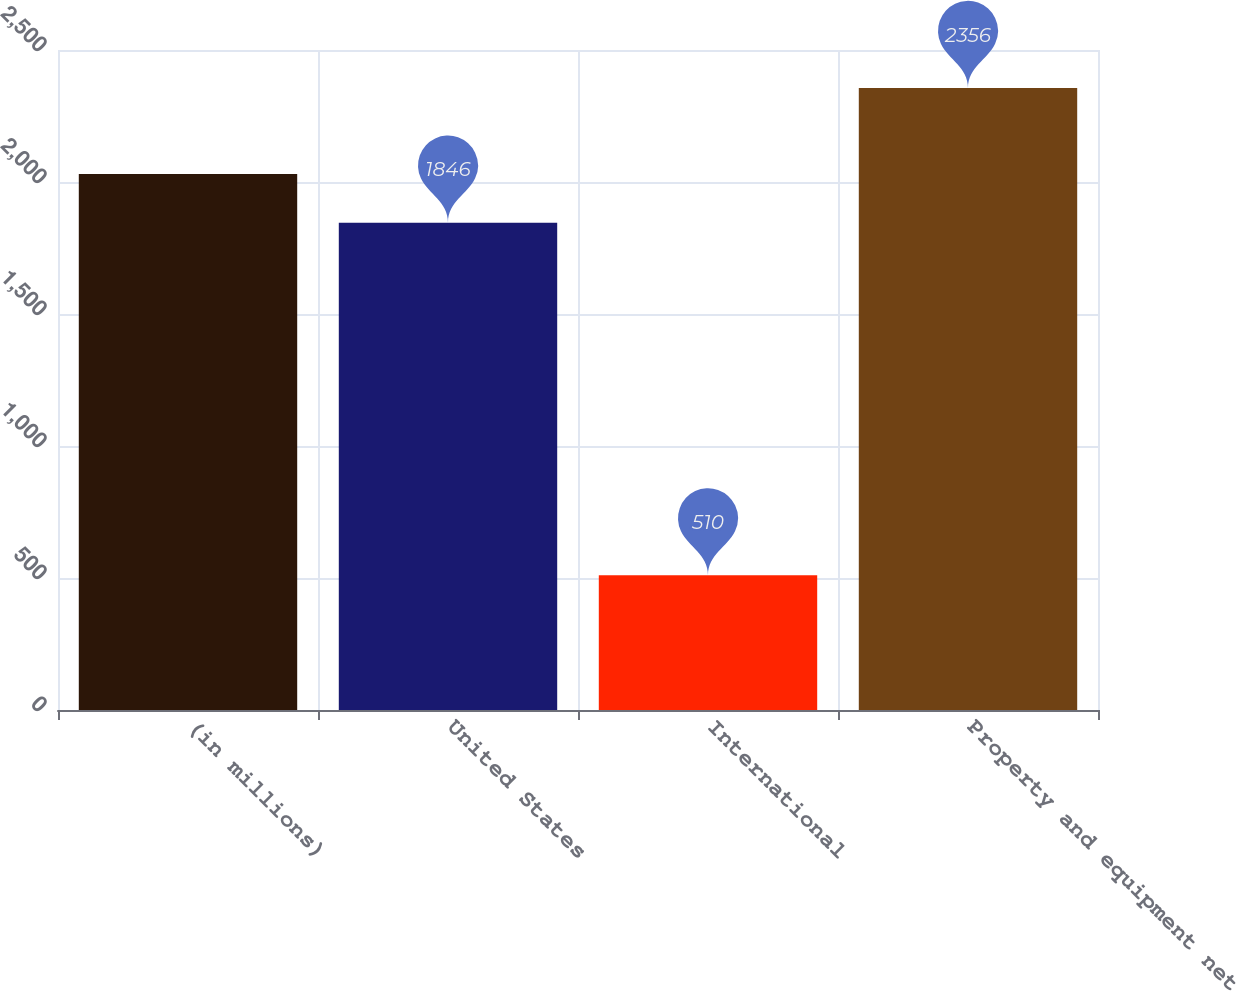Convert chart. <chart><loc_0><loc_0><loc_500><loc_500><bar_chart><fcel>(in millions)<fcel>United States<fcel>International<fcel>Property and equipment net<nl><fcel>2030.6<fcel>1846<fcel>510<fcel>2356<nl></chart> 